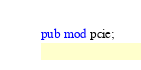Convert code to text. <code><loc_0><loc_0><loc_500><loc_500><_Rust_>pub mod pcie;
</code> 